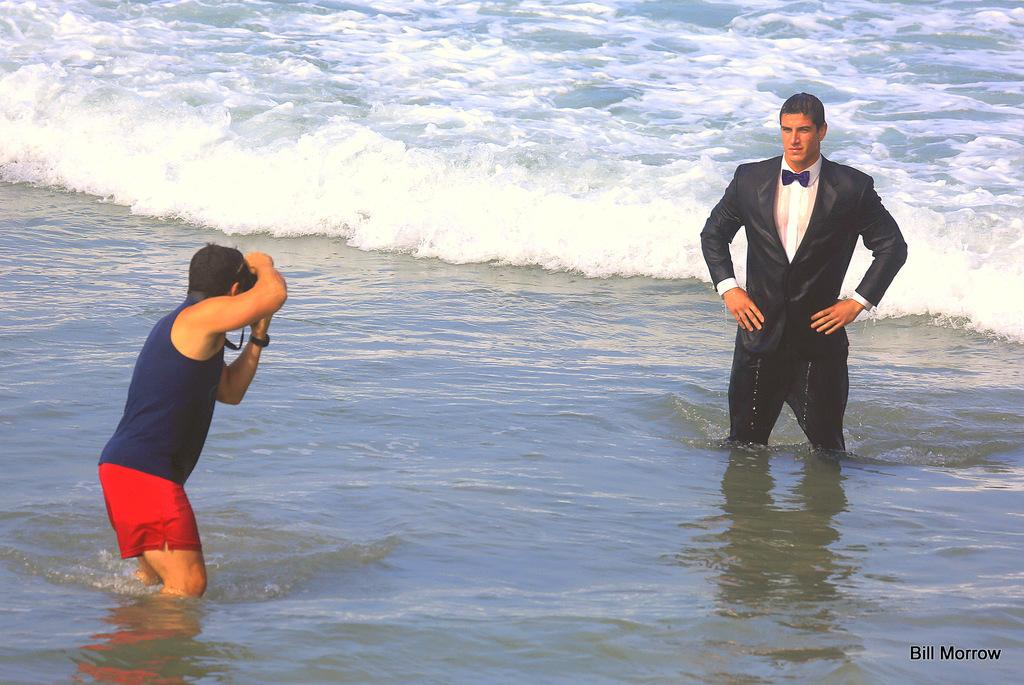What is the person in the image doing? The person is standing in the water and taking a picture of another person. What is the other person in the image doing? The other person is also standing in the water. What can be observed about the water in the image? There are waves visible in the image. What type of rod is being used by the person in the image? There is no rod present in the image; the person is taking a picture with a camera or smartphone. How does the pump affect the water in the image? There is no pump present in the image; it only features two people standing in the water and waves. 